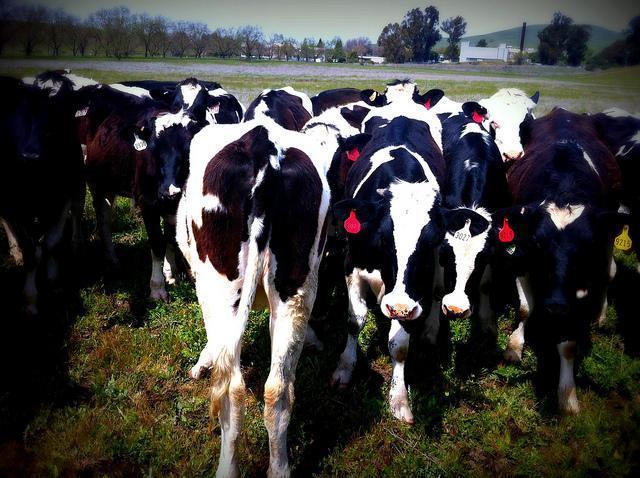How many cows can you see?
Give a very brief answer. 11. 